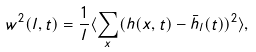<formula> <loc_0><loc_0><loc_500><loc_500>w ^ { 2 } ( l , t ) = \frac { 1 } { l } \langle \sum _ { x } ( h ( x , t ) - \bar { h } _ { l } ( t ) ) ^ { 2 } \rangle ,</formula> 